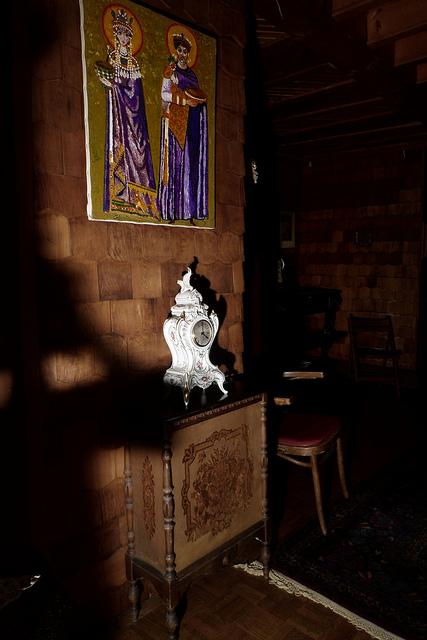IS it light or dark in the picture?
Short answer required. Dark. What is on the table?
Short answer required. Clock. Is there a heat source in the room?
Keep it brief. No. Are there flowers in this picture?
Give a very brief answer. No. What color is the wall?
Be succinct. Brown. Are there people in the picture?
Answer briefly. No. What is the white thing in the picture?
Concise answer only. Clock. How many pictures are in this photo?
Give a very brief answer. 1. What time is on the clock?
Answer briefly. 4:00. What style of painting is this?
Give a very brief answer. Medieval. Is it dark?
Quick response, please. Yes. What is on the delve?
Answer briefly. Clock. 